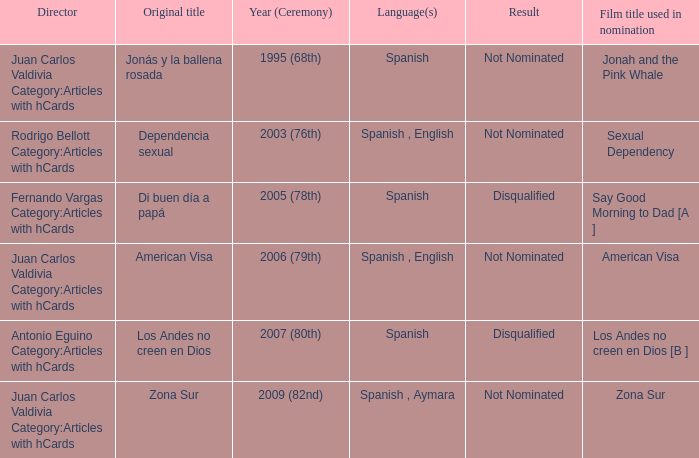What year was Zona Sur nominated? 2009 (82nd). 